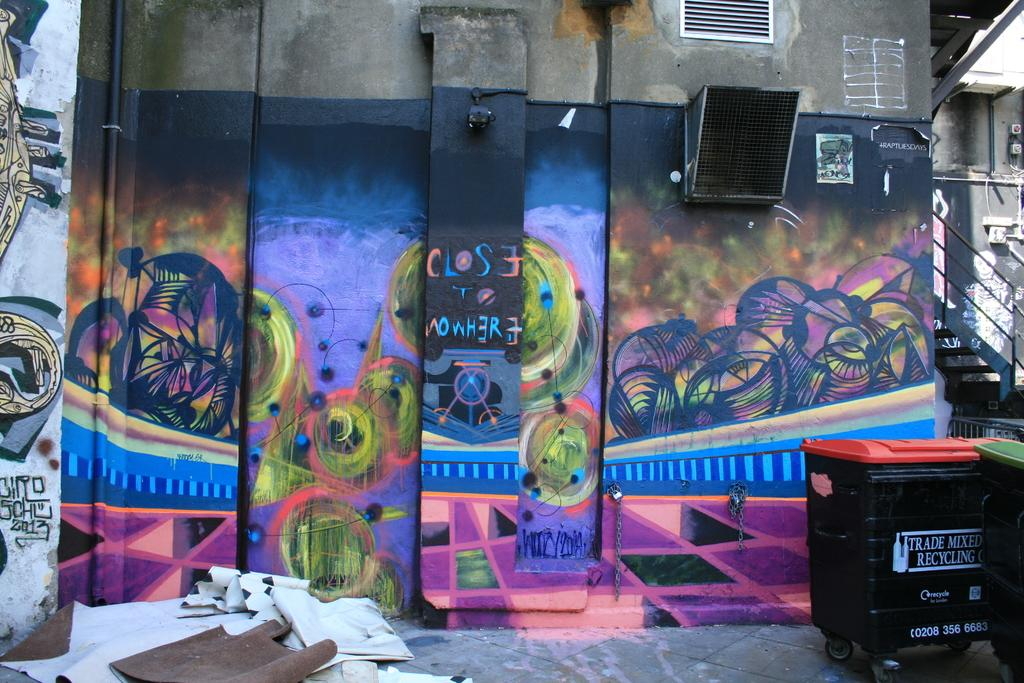<image>
Present a compact description of the photo's key features. A colorful wall mural with the words Close to Nowhere in the middle 